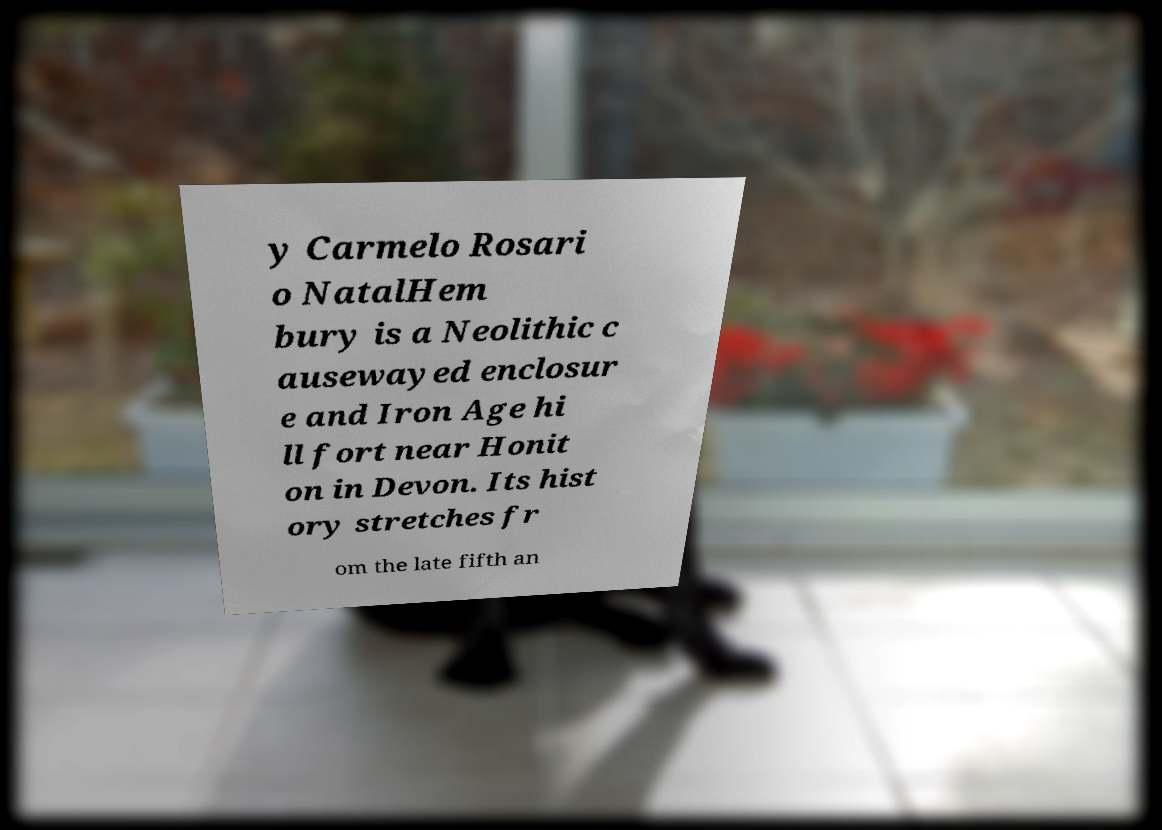Please read and relay the text visible in this image. What does it say? y Carmelo Rosari o NatalHem bury is a Neolithic c ausewayed enclosur e and Iron Age hi ll fort near Honit on in Devon. Its hist ory stretches fr om the late fifth an 